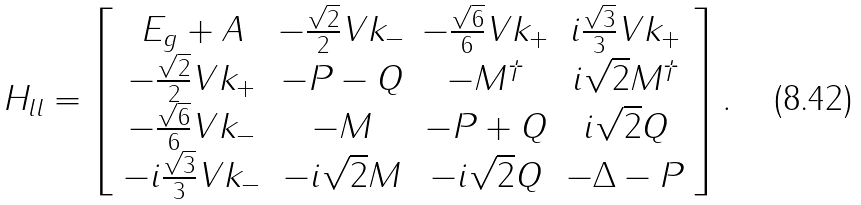Convert formula to latex. <formula><loc_0><loc_0><loc_500><loc_500>H _ { l l } = \left [ \begin{array} { c c c c } E _ { g } + A & - \frac { \sqrt { 2 } } { 2 } V k _ { - } & - \frac { \sqrt { 6 } } { 6 } V k _ { + } & i \frac { \sqrt { 3 } } { 3 } V k _ { + } \\ - \frac { \sqrt { 2 } } { 2 } V k _ { + } & - P - Q & - M ^ { \dag } & i \sqrt { 2 } M ^ { \dag } \\ - \frac { \sqrt { 6 } } { 6 } V k _ { - } & - M & - P + Q & i \sqrt { 2 } Q \\ - i \frac { \sqrt { 3 } } { 3 } V k _ { - } & - i \sqrt { 2 } M & - i \sqrt { 2 } Q & - \Delta - P \\ \end{array} \right ] .</formula> 